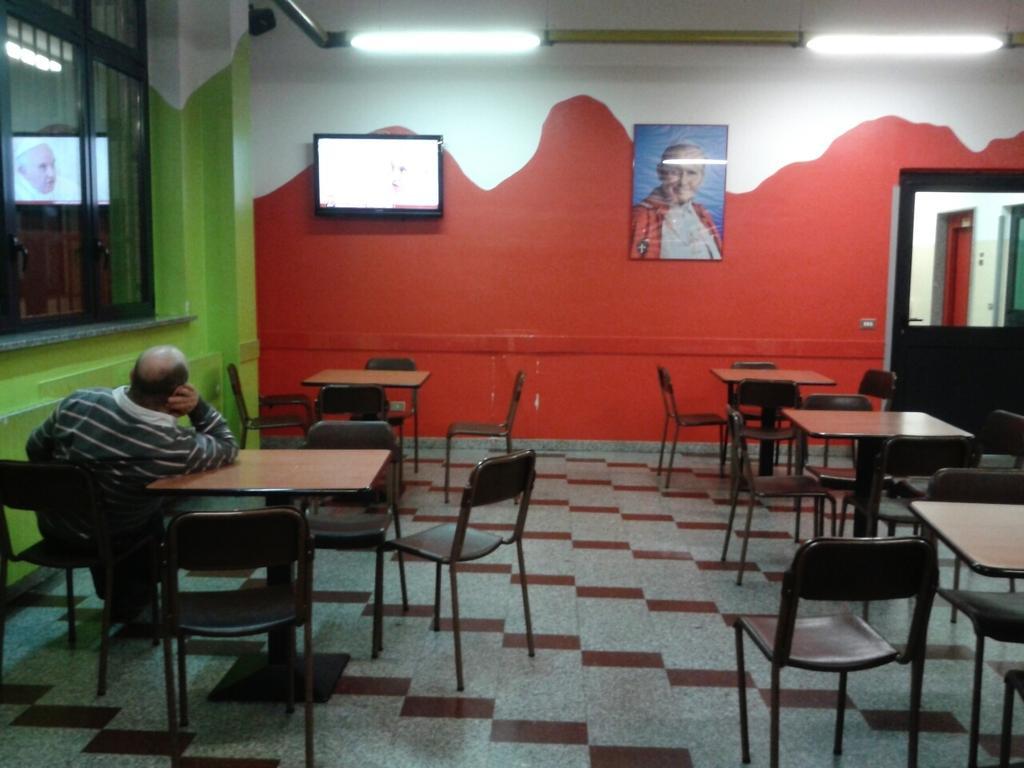How would you summarize this image in a sentence or two? In this image we can see chairs and a man sitting on one of it, tables, display screen, door, electric lights, windows and a photo frame to the wall. 